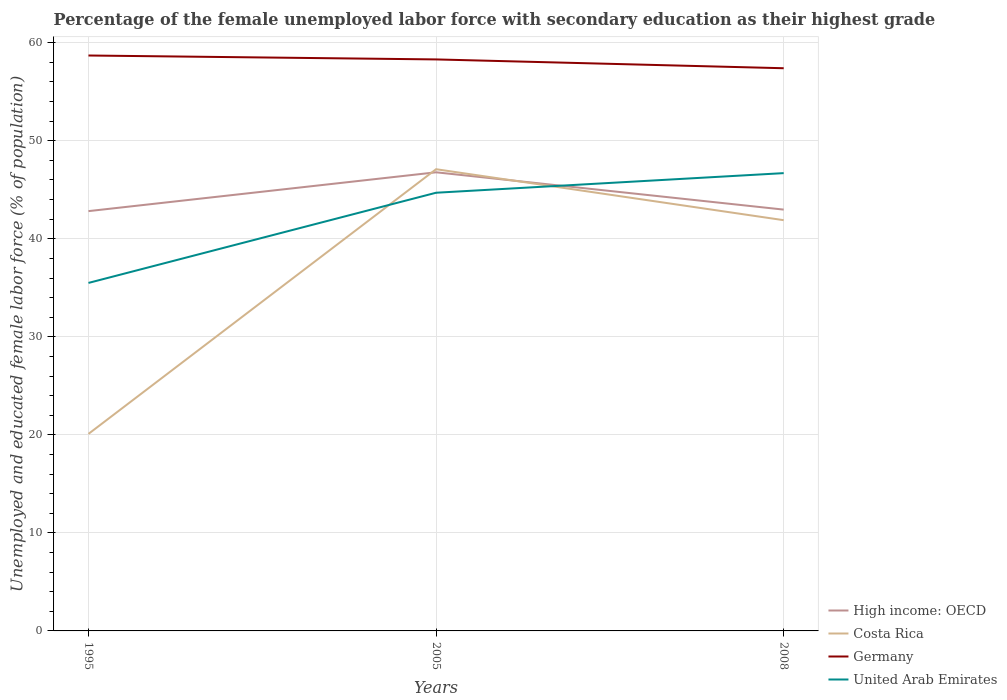Does the line corresponding to United Arab Emirates intersect with the line corresponding to High income: OECD?
Keep it short and to the point. Yes. Is the number of lines equal to the number of legend labels?
Make the answer very short. Yes. Across all years, what is the maximum percentage of the unemployed female labor force with secondary education in Costa Rica?
Your answer should be compact. 20.1. In which year was the percentage of the unemployed female labor force with secondary education in Germany maximum?
Ensure brevity in your answer.  2008. What is the difference between the highest and the second highest percentage of the unemployed female labor force with secondary education in United Arab Emirates?
Provide a short and direct response. 11.2. How many lines are there?
Your answer should be very brief. 4. Are the values on the major ticks of Y-axis written in scientific E-notation?
Your answer should be compact. No. Does the graph contain grids?
Keep it short and to the point. Yes. What is the title of the graph?
Offer a terse response. Percentage of the female unemployed labor force with secondary education as their highest grade. What is the label or title of the X-axis?
Provide a short and direct response. Years. What is the label or title of the Y-axis?
Your response must be concise. Unemployed and educated female labor force (% of population). What is the Unemployed and educated female labor force (% of population) of High income: OECD in 1995?
Make the answer very short. 42.82. What is the Unemployed and educated female labor force (% of population) of Costa Rica in 1995?
Offer a terse response. 20.1. What is the Unemployed and educated female labor force (% of population) in Germany in 1995?
Provide a succinct answer. 58.7. What is the Unemployed and educated female labor force (% of population) in United Arab Emirates in 1995?
Your answer should be very brief. 35.5. What is the Unemployed and educated female labor force (% of population) in High income: OECD in 2005?
Offer a very short reply. 46.78. What is the Unemployed and educated female labor force (% of population) in Costa Rica in 2005?
Your answer should be compact. 47.1. What is the Unemployed and educated female labor force (% of population) in Germany in 2005?
Your answer should be very brief. 58.3. What is the Unemployed and educated female labor force (% of population) of United Arab Emirates in 2005?
Give a very brief answer. 44.7. What is the Unemployed and educated female labor force (% of population) in High income: OECD in 2008?
Your answer should be very brief. 42.98. What is the Unemployed and educated female labor force (% of population) in Costa Rica in 2008?
Give a very brief answer. 41.9. What is the Unemployed and educated female labor force (% of population) in Germany in 2008?
Provide a short and direct response. 57.4. What is the Unemployed and educated female labor force (% of population) in United Arab Emirates in 2008?
Offer a terse response. 46.7. Across all years, what is the maximum Unemployed and educated female labor force (% of population) in High income: OECD?
Your answer should be compact. 46.78. Across all years, what is the maximum Unemployed and educated female labor force (% of population) in Costa Rica?
Offer a terse response. 47.1. Across all years, what is the maximum Unemployed and educated female labor force (% of population) of Germany?
Your answer should be compact. 58.7. Across all years, what is the maximum Unemployed and educated female labor force (% of population) of United Arab Emirates?
Give a very brief answer. 46.7. Across all years, what is the minimum Unemployed and educated female labor force (% of population) of High income: OECD?
Your response must be concise. 42.82. Across all years, what is the minimum Unemployed and educated female labor force (% of population) of Costa Rica?
Your answer should be very brief. 20.1. Across all years, what is the minimum Unemployed and educated female labor force (% of population) in Germany?
Provide a succinct answer. 57.4. Across all years, what is the minimum Unemployed and educated female labor force (% of population) in United Arab Emirates?
Ensure brevity in your answer.  35.5. What is the total Unemployed and educated female labor force (% of population) of High income: OECD in the graph?
Offer a terse response. 132.59. What is the total Unemployed and educated female labor force (% of population) of Costa Rica in the graph?
Offer a very short reply. 109.1. What is the total Unemployed and educated female labor force (% of population) of Germany in the graph?
Ensure brevity in your answer.  174.4. What is the total Unemployed and educated female labor force (% of population) in United Arab Emirates in the graph?
Your answer should be compact. 126.9. What is the difference between the Unemployed and educated female labor force (% of population) of High income: OECD in 1995 and that in 2005?
Your answer should be compact. -3.96. What is the difference between the Unemployed and educated female labor force (% of population) of High income: OECD in 1995 and that in 2008?
Offer a very short reply. -0.16. What is the difference between the Unemployed and educated female labor force (% of population) in Costa Rica in 1995 and that in 2008?
Provide a succinct answer. -21.8. What is the difference between the Unemployed and educated female labor force (% of population) of High income: OECD in 2005 and that in 2008?
Provide a succinct answer. 3.81. What is the difference between the Unemployed and educated female labor force (% of population) in Costa Rica in 2005 and that in 2008?
Your answer should be compact. 5.2. What is the difference between the Unemployed and educated female labor force (% of population) of Germany in 2005 and that in 2008?
Make the answer very short. 0.9. What is the difference between the Unemployed and educated female labor force (% of population) in High income: OECD in 1995 and the Unemployed and educated female labor force (% of population) in Costa Rica in 2005?
Keep it short and to the point. -4.28. What is the difference between the Unemployed and educated female labor force (% of population) of High income: OECD in 1995 and the Unemployed and educated female labor force (% of population) of Germany in 2005?
Your answer should be compact. -15.48. What is the difference between the Unemployed and educated female labor force (% of population) in High income: OECD in 1995 and the Unemployed and educated female labor force (% of population) in United Arab Emirates in 2005?
Your answer should be very brief. -1.88. What is the difference between the Unemployed and educated female labor force (% of population) in Costa Rica in 1995 and the Unemployed and educated female labor force (% of population) in Germany in 2005?
Offer a very short reply. -38.2. What is the difference between the Unemployed and educated female labor force (% of population) in Costa Rica in 1995 and the Unemployed and educated female labor force (% of population) in United Arab Emirates in 2005?
Offer a terse response. -24.6. What is the difference between the Unemployed and educated female labor force (% of population) of Germany in 1995 and the Unemployed and educated female labor force (% of population) of United Arab Emirates in 2005?
Ensure brevity in your answer.  14. What is the difference between the Unemployed and educated female labor force (% of population) of High income: OECD in 1995 and the Unemployed and educated female labor force (% of population) of Costa Rica in 2008?
Give a very brief answer. 0.92. What is the difference between the Unemployed and educated female labor force (% of population) in High income: OECD in 1995 and the Unemployed and educated female labor force (% of population) in Germany in 2008?
Provide a short and direct response. -14.58. What is the difference between the Unemployed and educated female labor force (% of population) of High income: OECD in 1995 and the Unemployed and educated female labor force (% of population) of United Arab Emirates in 2008?
Offer a terse response. -3.88. What is the difference between the Unemployed and educated female labor force (% of population) of Costa Rica in 1995 and the Unemployed and educated female labor force (% of population) of Germany in 2008?
Make the answer very short. -37.3. What is the difference between the Unemployed and educated female labor force (% of population) in Costa Rica in 1995 and the Unemployed and educated female labor force (% of population) in United Arab Emirates in 2008?
Your response must be concise. -26.6. What is the difference between the Unemployed and educated female labor force (% of population) of High income: OECD in 2005 and the Unemployed and educated female labor force (% of population) of Costa Rica in 2008?
Provide a succinct answer. 4.88. What is the difference between the Unemployed and educated female labor force (% of population) of High income: OECD in 2005 and the Unemployed and educated female labor force (% of population) of Germany in 2008?
Keep it short and to the point. -10.62. What is the difference between the Unemployed and educated female labor force (% of population) of High income: OECD in 2005 and the Unemployed and educated female labor force (% of population) of United Arab Emirates in 2008?
Keep it short and to the point. 0.08. What is the difference between the Unemployed and educated female labor force (% of population) of Costa Rica in 2005 and the Unemployed and educated female labor force (% of population) of Germany in 2008?
Your answer should be compact. -10.3. What is the difference between the Unemployed and educated female labor force (% of population) of Costa Rica in 2005 and the Unemployed and educated female labor force (% of population) of United Arab Emirates in 2008?
Provide a short and direct response. 0.4. What is the difference between the Unemployed and educated female labor force (% of population) in Germany in 2005 and the Unemployed and educated female labor force (% of population) in United Arab Emirates in 2008?
Offer a terse response. 11.6. What is the average Unemployed and educated female labor force (% of population) of High income: OECD per year?
Your answer should be very brief. 44.2. What is the average Unemployed and educated female labor force (% of population) in Costa Rica per year?
Your answer should be compact. 36.37. What is the average Unemployed and educated female labor force (% of population) of Germany per year?
Provide a short and direct response. 58.13. What is the average Unemployed and educated female labor force (% of population) in United Arab Emirates per year?
Give a very brief answer. 42.3. In the year 1995, what is the difference between the Unemployed and educated female labor force (% of population) of High income: OECD and Unemployed and educated female labor force (% of population) of Costa Rica?
Give a very brief answer. 22.72. In the year 1995, what is the difference between the Unemployed and educated female labor force (% of population) in High income: OECD and Unemployed and educated female labor force (% of population) in Germany?
Ensure brevity in your answer.  -15.88. In the year 1995, what is the difference between the Unemployed and educated female labor force (% of population) of High income: OECD and Unemployed and educated female labor force (% of population) of United Arab Emirates?
Keep it short and to the point. 7.32. In the year 1995, what is the difference between the Unemployed and educated female labor force (% of population) of Costa Rica and Unemployed and educated female labor force (% of population) of Germany?
Offer a very short reply. -38.6. In the year 1995, what is the difference between the Unemployed and educated female labor force (% of population) of Costa Rica and Unemployed and educated female labor force (% of population) of United Arab Emirates?
Your response must be concise. -15.4. In the year 1995, what is the difference between the Unemployed and educated female labor force (% of population) in Germany and Unemployed and educated female labor force (% of population) in United Arab Emirates?
Make the answer very short. 23.2. In the year 2005, what is the difference between the Unemployed and educated female labor force (% of population) in High income: OECD and Unemployed and educated female labor force (% of population) in Costa Rica?
Your response must be concise. -0.32. In the year 2005, what is the difference between the Unemployed and educated female labor force (% of population) in High income: OECD and Unemployed and educated female labor force (% of population) in Germany?
Your answer should be very brief. -11.52. In the year 2005, what is the difference between the Unemployed and educated female labor force (% of population) of High income: OECD and Unemployed and educated female labor force (% of population) of United Arab Emirates?
Ensure brevity in your answer.  2.08. In the year 2005, what is the difference between the Unemployed and educated female labor force (% of population) of Costa Rica and Unemployed and educated female labor force (% of population) of Germany?
Provide a succinct answer. -11.2. In the year 2005, what is the difference between the Unemployed and educated female labor force (% of population) of Germany and Unemployed and educated female labor force (% of population) of United Arab Emirates?
Provide a succinct answer. 13.6. In the year 2008, what is the difference between the Unemployed and educated female labor force (% of population) of High income: OECD and Unemployed and educated female labor force (% of population) of Costa Rica?
Provide a short and direct response. 1.08. In the year 2008, what is the difference between the Unemployed and educated female labor force (% of population) in High income: OECD and Unemployed and educated female labor force (% of population) in Germany?
Keep it short and to the point. -14.42. In the year 2008, what is the difference between the Unemployed and educated female labor force (% of population) in High income: OECD and Unemployed and educated female labor force (% of population) in United Arab Emirates?
Your response must be concise. -3.72. In the year 2008, what is the difference between the Unemployed and educated female labor force (% of population) of Costa Rica and Unemployed and educated female labor force (% of population) of Germany?
Make the answer very short. -15.5. In the year 2008, what is the difference between the Unemployed and educated female labor force (% of population) in Costa Rica and Unemployed and educated female labor force (% of population) in United Arab Emirates?
Offer a terse response. -4.8. In the year 2008, what is the difference between the Unemployed and educated female labor force (% of population) in Germany and Unemployed and educated female labor force (% of population) in United Arab Emirates?
Provide a short and direct response. 10.7. What is the ratio of the Unemployed and educated female labor force (% of population) in High income: OECD in 1995 to that in 2005?
Keep it short and to the point. 0.92. What is the ratio of the Unemployed and educated female labor force (% of population) in Costa Rica in 1995 to that in 2005?
Your answer should be very brief. 0.43. What is the ratio of the Unemployed and educated female labor force (% of population) in Germany in 1995 to that in 2005?
Your answer should be very brief. 1.01. What is the ratio of the Unemployed and educated female labor force (% of population) in United Arab Emirates in 1995 to that in 2005?
Your response must be concise. 0.79. What is the ratio of the Unemployed and educated female labor force (% of population) of Costa Rica in 1995 to that in 2008?
Your response must be concise. 0.48. What is the ratio of the Unemployed and educated female labor force (% of population) in Germany in 1995 to that in 2008?
Ensure brevity in your answer.  1.02. What is the ratio of the Unemployed and educated female labor force (% of population) in United Arab Emirates in 1995 to that in 2008?
Offer a terse response. 0.76. What is the ratio of the Unemployed and educated female labor force (% of population) in High income: OECD in 2005 to that in 2008?
Ensure brevity in your answer.  1.09. What is the ratio of the Unemployed and educated female labor force (% of population) of Costa Rica in 2005 to that in 2008?
Make the answer very short. 1.12. What is the ratio of the Unemployed and educated female labor force (% of population) of Germany in 2005 to that in 2008?
Ensure brevity in your answer.  1.02. What is the ratio of the Unemployed and educated female labor force (% of population) of United Arab Emirates in 2005 to that in 2008?
Offer a very short reply. 0.96. What is the difference between the highest and the second highest Unemployed and educated female labor force (% of population) in High income: OECD?
Give a very brief answer. 3.81. What is the difference between the highest and the second highest Unemployed and educated female labor force (% of population) of Costa Rica?
Provide a succinct answer. 5.2. What is the difference between the highest and the second highest Unemployed and educated female labor force (% of population) in Germany?
Your answer should be very brief. 0.4. What is the difference between the highest and the second highest Unemployed and educated female labor force (% of population) of United Arab Emirates?
Give a very brief answer. 2. What is the difference between the highest and the lowest Unemployed and educated female labor force (% of population) in High income: OECD?
Keep it short and to the point. 3.96. What is the difference between the highest and the lowest Unemployed and educated female labor force (% of population) in Germany?
Your answer should be compact. 1.3. 